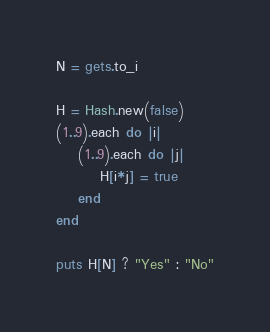Convert code to text. <code><loc_0><loc_0><loc_500><loc_500><_Ruby_>N = gets.to_i

H = Hash.new(false)
(1..9).each do |i|
    (1..9).each do |j|
        H[i*j] = true
    end
end

puts H[N] ? "Yes" : "No"</code> 